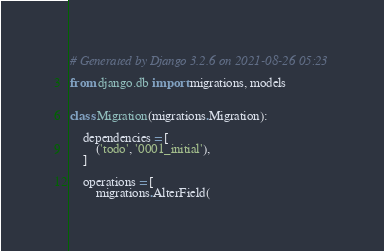Convert code to text. <code><loc_0><loc_0><loc_500><loc_500><_Python_># Generated by Django 3.2.6 on 2021-08-26 05:23

from django.db import migrations, models


class Migration(migrations.Migration):

    dependencies = [
        ('todo', '0001_initial'),
    ]

    operations = [
        migrations.AlterField(</code> 